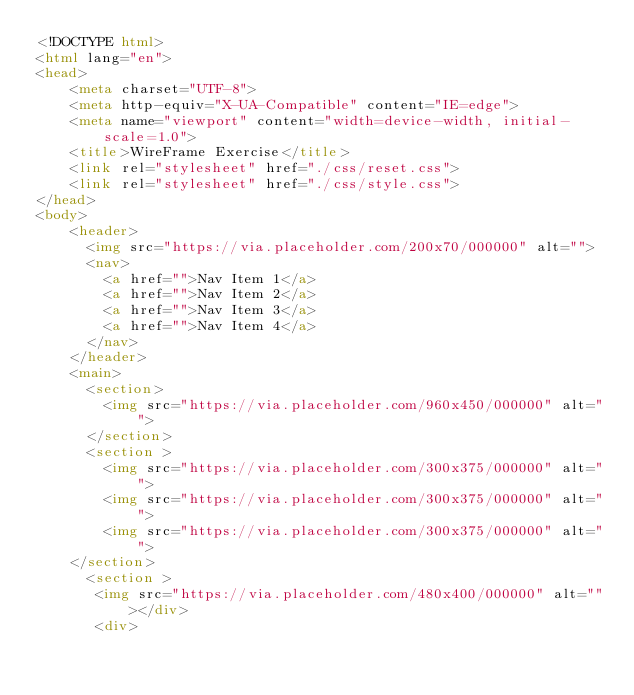Convert code to text. <code><loc_0><loc_0><loc_500><loc_500><_HTML_><!DOCTYPE html>
<html lang="en">
<head>
    <meta charset="UTF-8">
    <meta http-equiv="X-UA-Compatible" content="IE=edge">
    <meta name="viewport" content="width=device-width, initial-scale=1.0">
    <title>WireFrame Exercise</title>
    <link rel="stylesheet" href="./css/reset.css">
    <link rel="stylesheet" href="./css/style.css">
</head>
<body>
    <header>
      <img src="https://via.placeholder.com/200x70/000000" alt="">
      <nav>
        <a href="">Nav Item 1</a>
        <a href="">Nav Item 2</a>
        <a href="">Nav Item 3</a>
        <a href="">Nav Item 4</a>
      </nav>
    </header>
    <main>
      <section>
        <img src="https://via.placeholder.com/960x450/000000" alt="">
      </section>
      <section >
        <img src="https://via.placeholder.com/300x375/000000" alt="">
        <img src="https://via.placeholder.com/300x375/000000" alt="">
        <img src="https://via.placeholder.com/300x375/000000" alt="">
    </section>
      <section >
       <img src="https://via.placeholder.com/480x400/000000" alt=""></div>
       <div></code> 